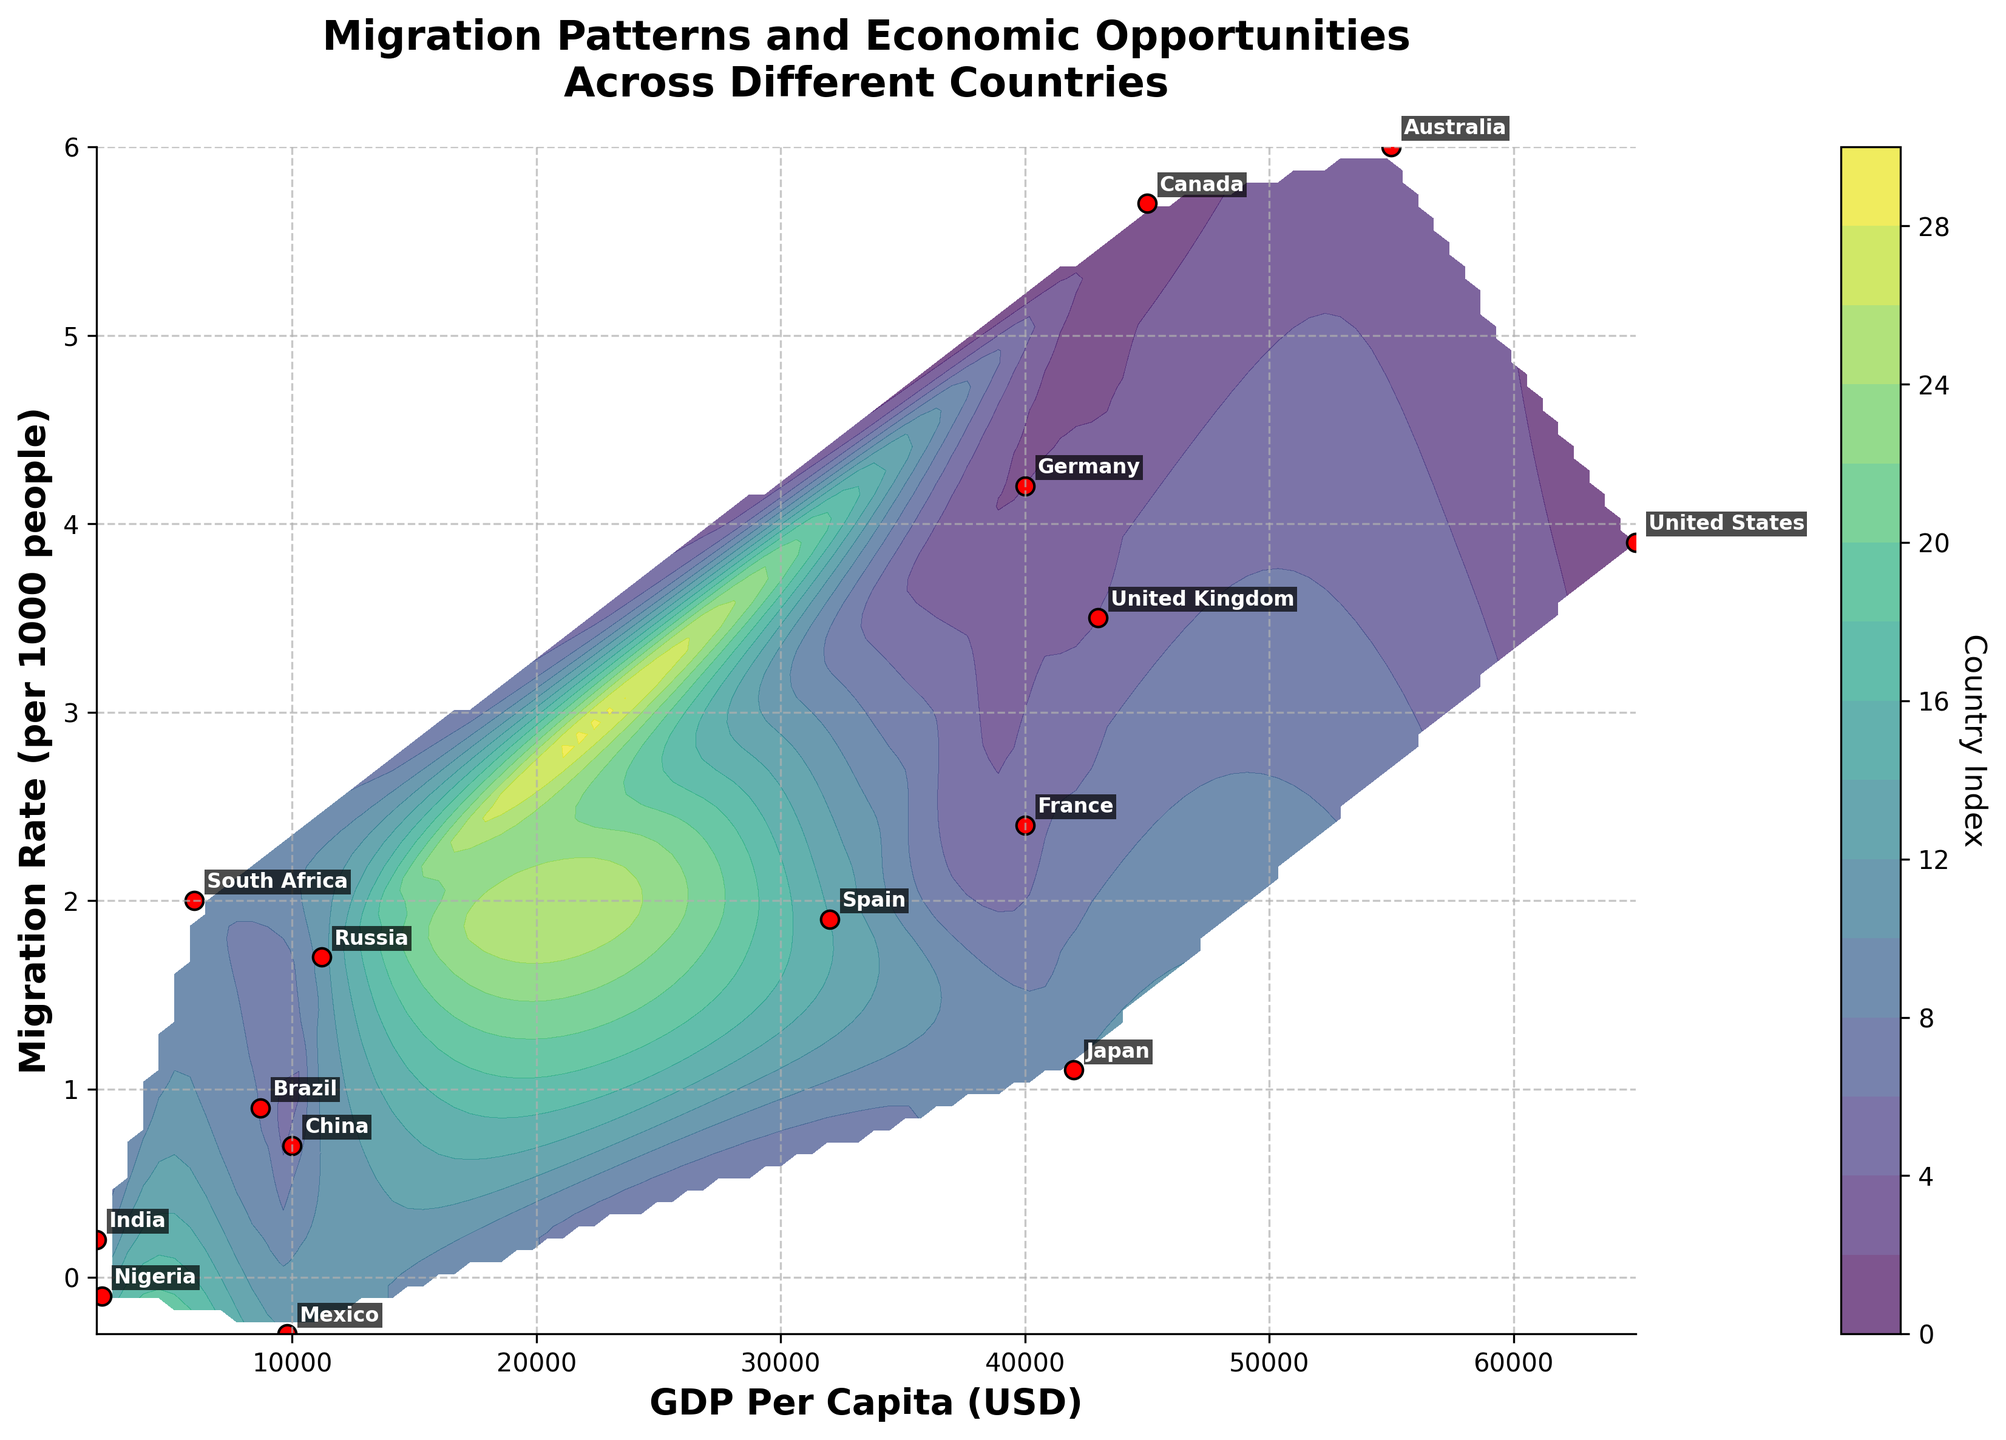What is the title of the figure? The title is usually displayed prominently at the top of the plot. In this figure, it reads "Migration Patterns and Economic Opportunities Across Different Countries."
Answer: Migration Patterns and Economic Opportunities Across Different Countries Which country has the highest GDP per capita? By looking at the x-axis and identifying the highest value, we can see the United States has the highest GDP per capita, which is $65,000.
Answer: United States How many countries have a negative migration rate? By looking at the y-axis, we identify the countries below the 0 mark. Both Mexico and Nigeria have negative migration rates.
Answer: 2 Which country has the highest migration rate and what is its GDP per capita? Observing the y-axis for the highest point, Australia has the highest migration rate of 6.0 per 1000 people, with its GDP per capita being $55,000.
Answer: Australia, $55,000 How does India’s GDP per capita compare to China’s? Locate both India and China’s positions along the x-axis. India has a GDP per capita of $2000, while China’s is $10,000, indicating China’s GDP per capita is higher than India’s.
Answer: China’s GDP per capita is higher What is the migration rate spread across the countries? Look at the y-axis for the range of migration rates. The highest rate is 6.0 (Australia) and the lowest is -0.3 (Mexico). The spread is 6.0 - (-0.3) = 6.3.
Answer: 6.3 per 1000 people Which countries have a GDP per capita between $40,000 to $50,000? By examining the x-axis and labels, Germany ($40,000), the United Kingdom ($43,000), and Canada ($45,000) fall within this range.
Answer: Germany, United Kingdom, Canada Which country has a lower migration rate: Japan or South Africa? Locate both countries on the y-axis. Japan has a migration rate of 1.1, and South Africa has a rate of 2.0, making Japan's rate lower.
Answer: Japan How many countries have GDP per capita less than $10,000? Identifying countries on the x-axis with values below $10,000, we find India, Nigeria, Brazil, Mexico, and Russia fit this category.
Answer: 5 What is the color scheme used in the contour plot? The color scheme is visible in the contour areas of the plot, with varying shades representing different levels. This plot uses a ‘viridis’ color map as indicated by the gradual color transitions from lower to higher index values.
Answer: viridis 